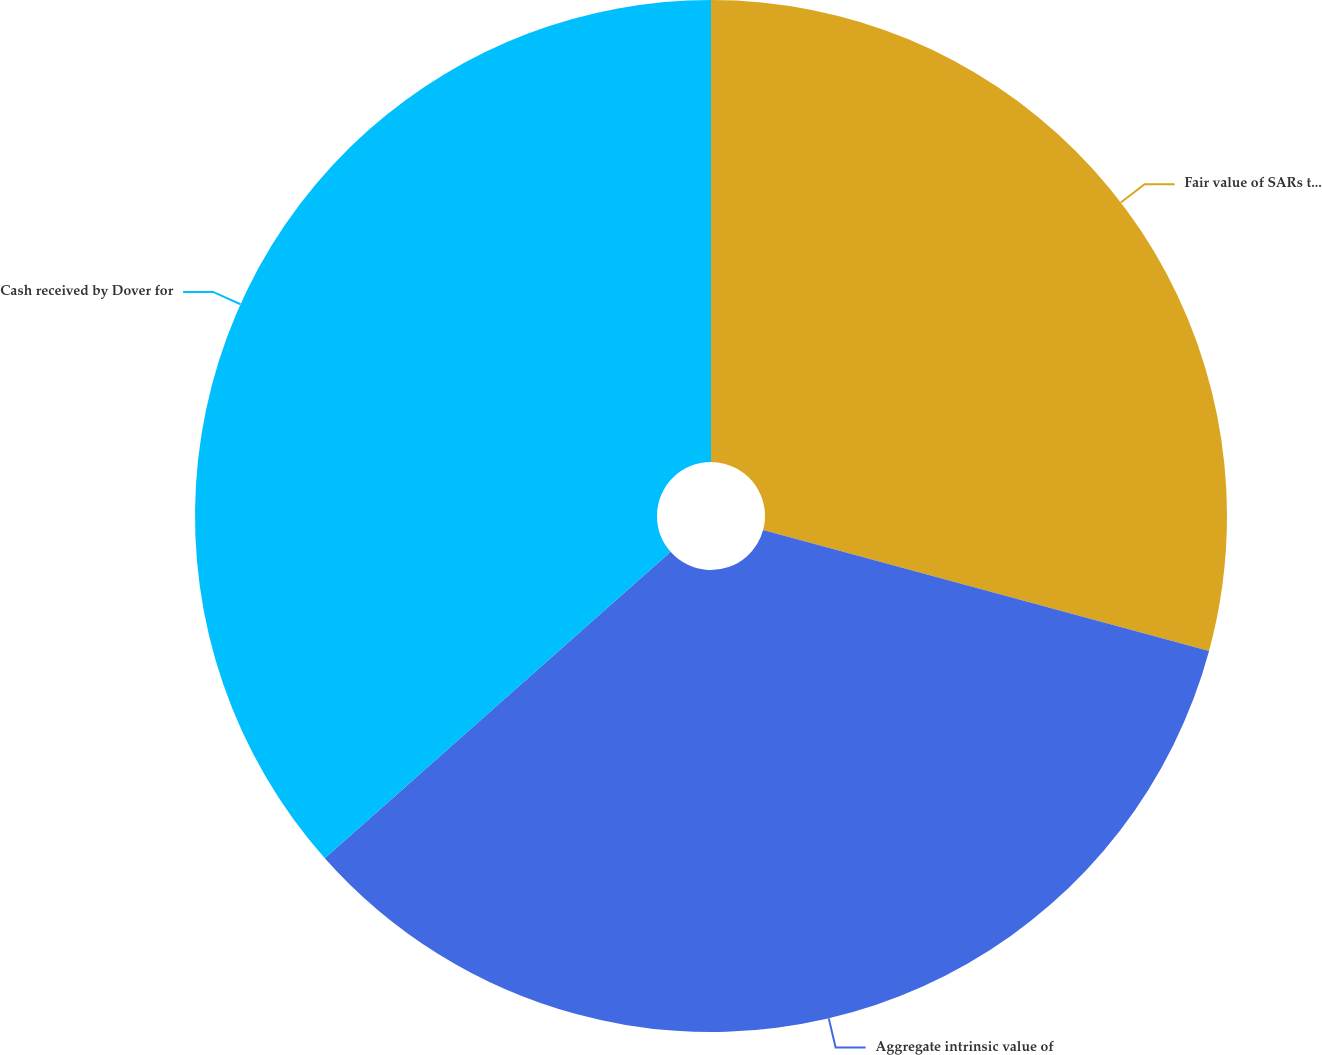Convert chart. <chart><loc_0><loc_0><loc_500><loc_500><pie_chart><fcel>Fair value of SARs that became<fcel>Aggregate intrinsic value of<fcel>Cash received by Dover for<nl><fcel>29.21%<fcel>34.25%<fcel>36.54%<nl></chart> 